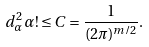<formula> <loc_0><loc_0><loc_500><loc_500>d _ { \alpha } ^ { 2 } \alpha ! \leq C = \frac { 1 } { ( 2 \pi ) ^ { m / 2 } } .</formula> 